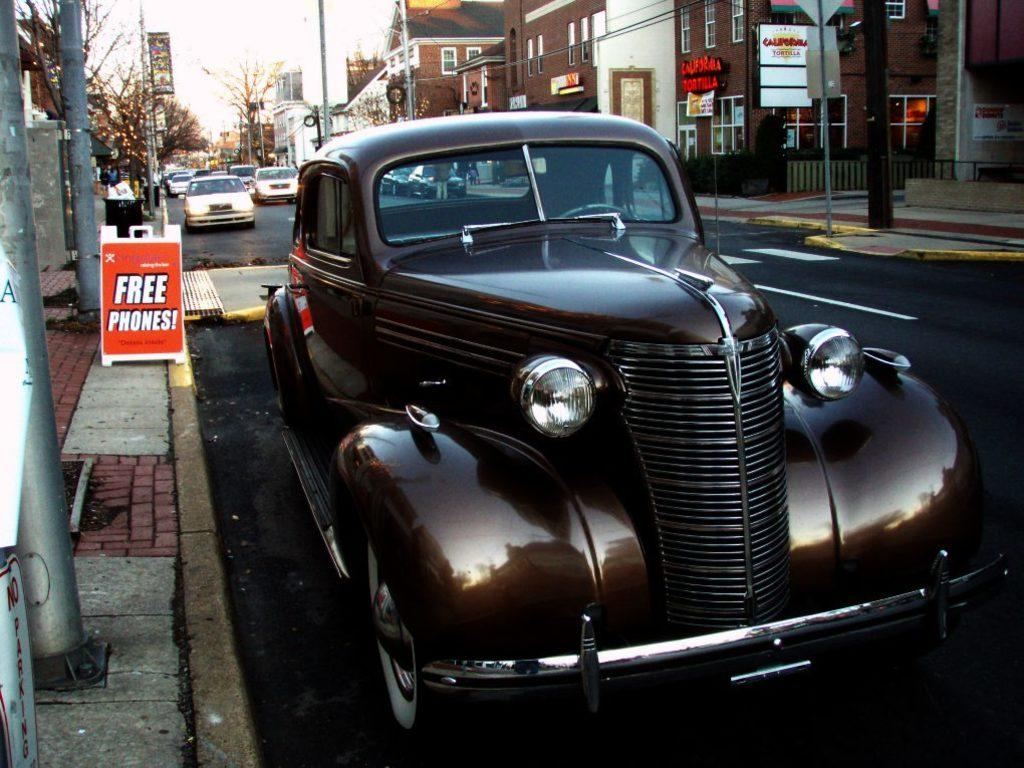<image>
Provide a brief description of the given image. Black car park on the street next to a free phones sign 